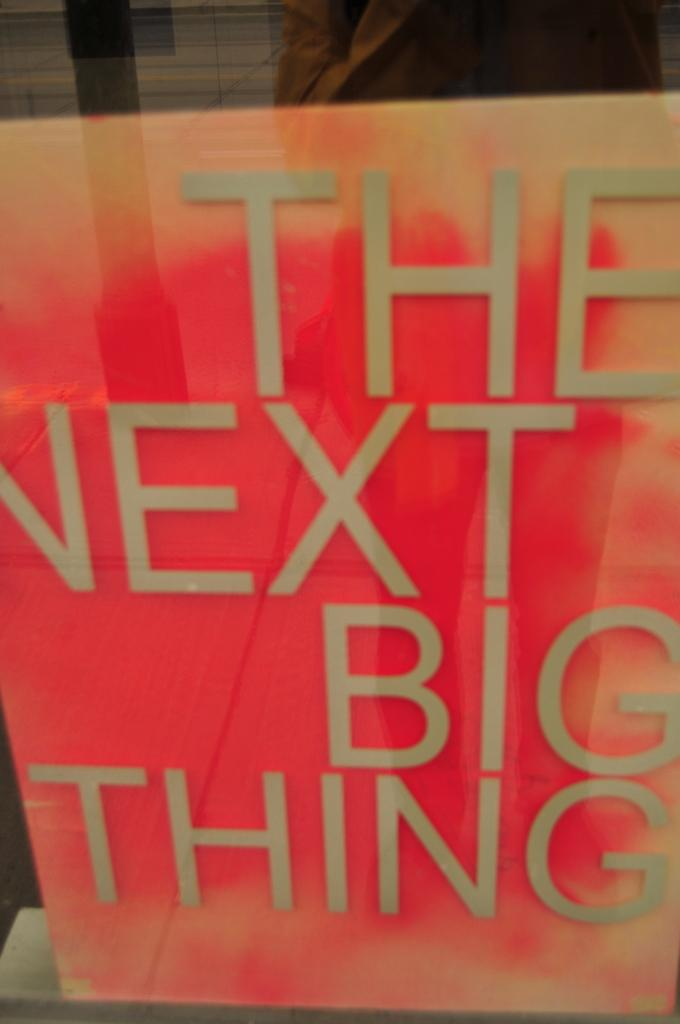<image>
Relay a brief, clear account of the picture shown. A bright pink sign reads "The Next Big Thing." 